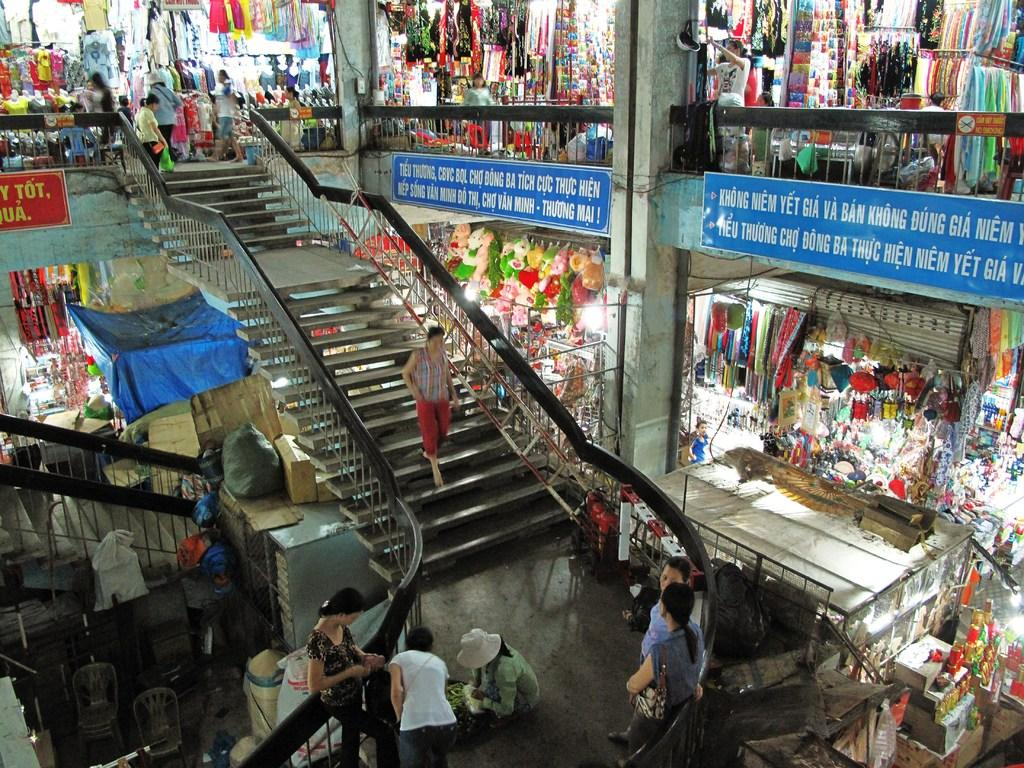What type of establishments can be seen in the image? There are stores in the image. What items are visible in the stores? There are teddies in the image. What type of signage is present in the image? There are sign boards in the image. What objects are used for storage or packaging in the image? There are cardboard boxes in the image. Are there any people present in the image? Yes, there are people in the image. What architectural features can be seen in the image? There are steps, chairs, railings, and pillars in the image. What other objects are present in the image? There are boards in the image. How many sisters are walking together in the image? There is no mention of sisters or walking in the image; it features stores, teddies, sign boards, cardboard boxes, people, steps, chairs, railings, pillars, and boards. What type of education is being provided in the image? There is no indication of any educational activity or institution in the image. 